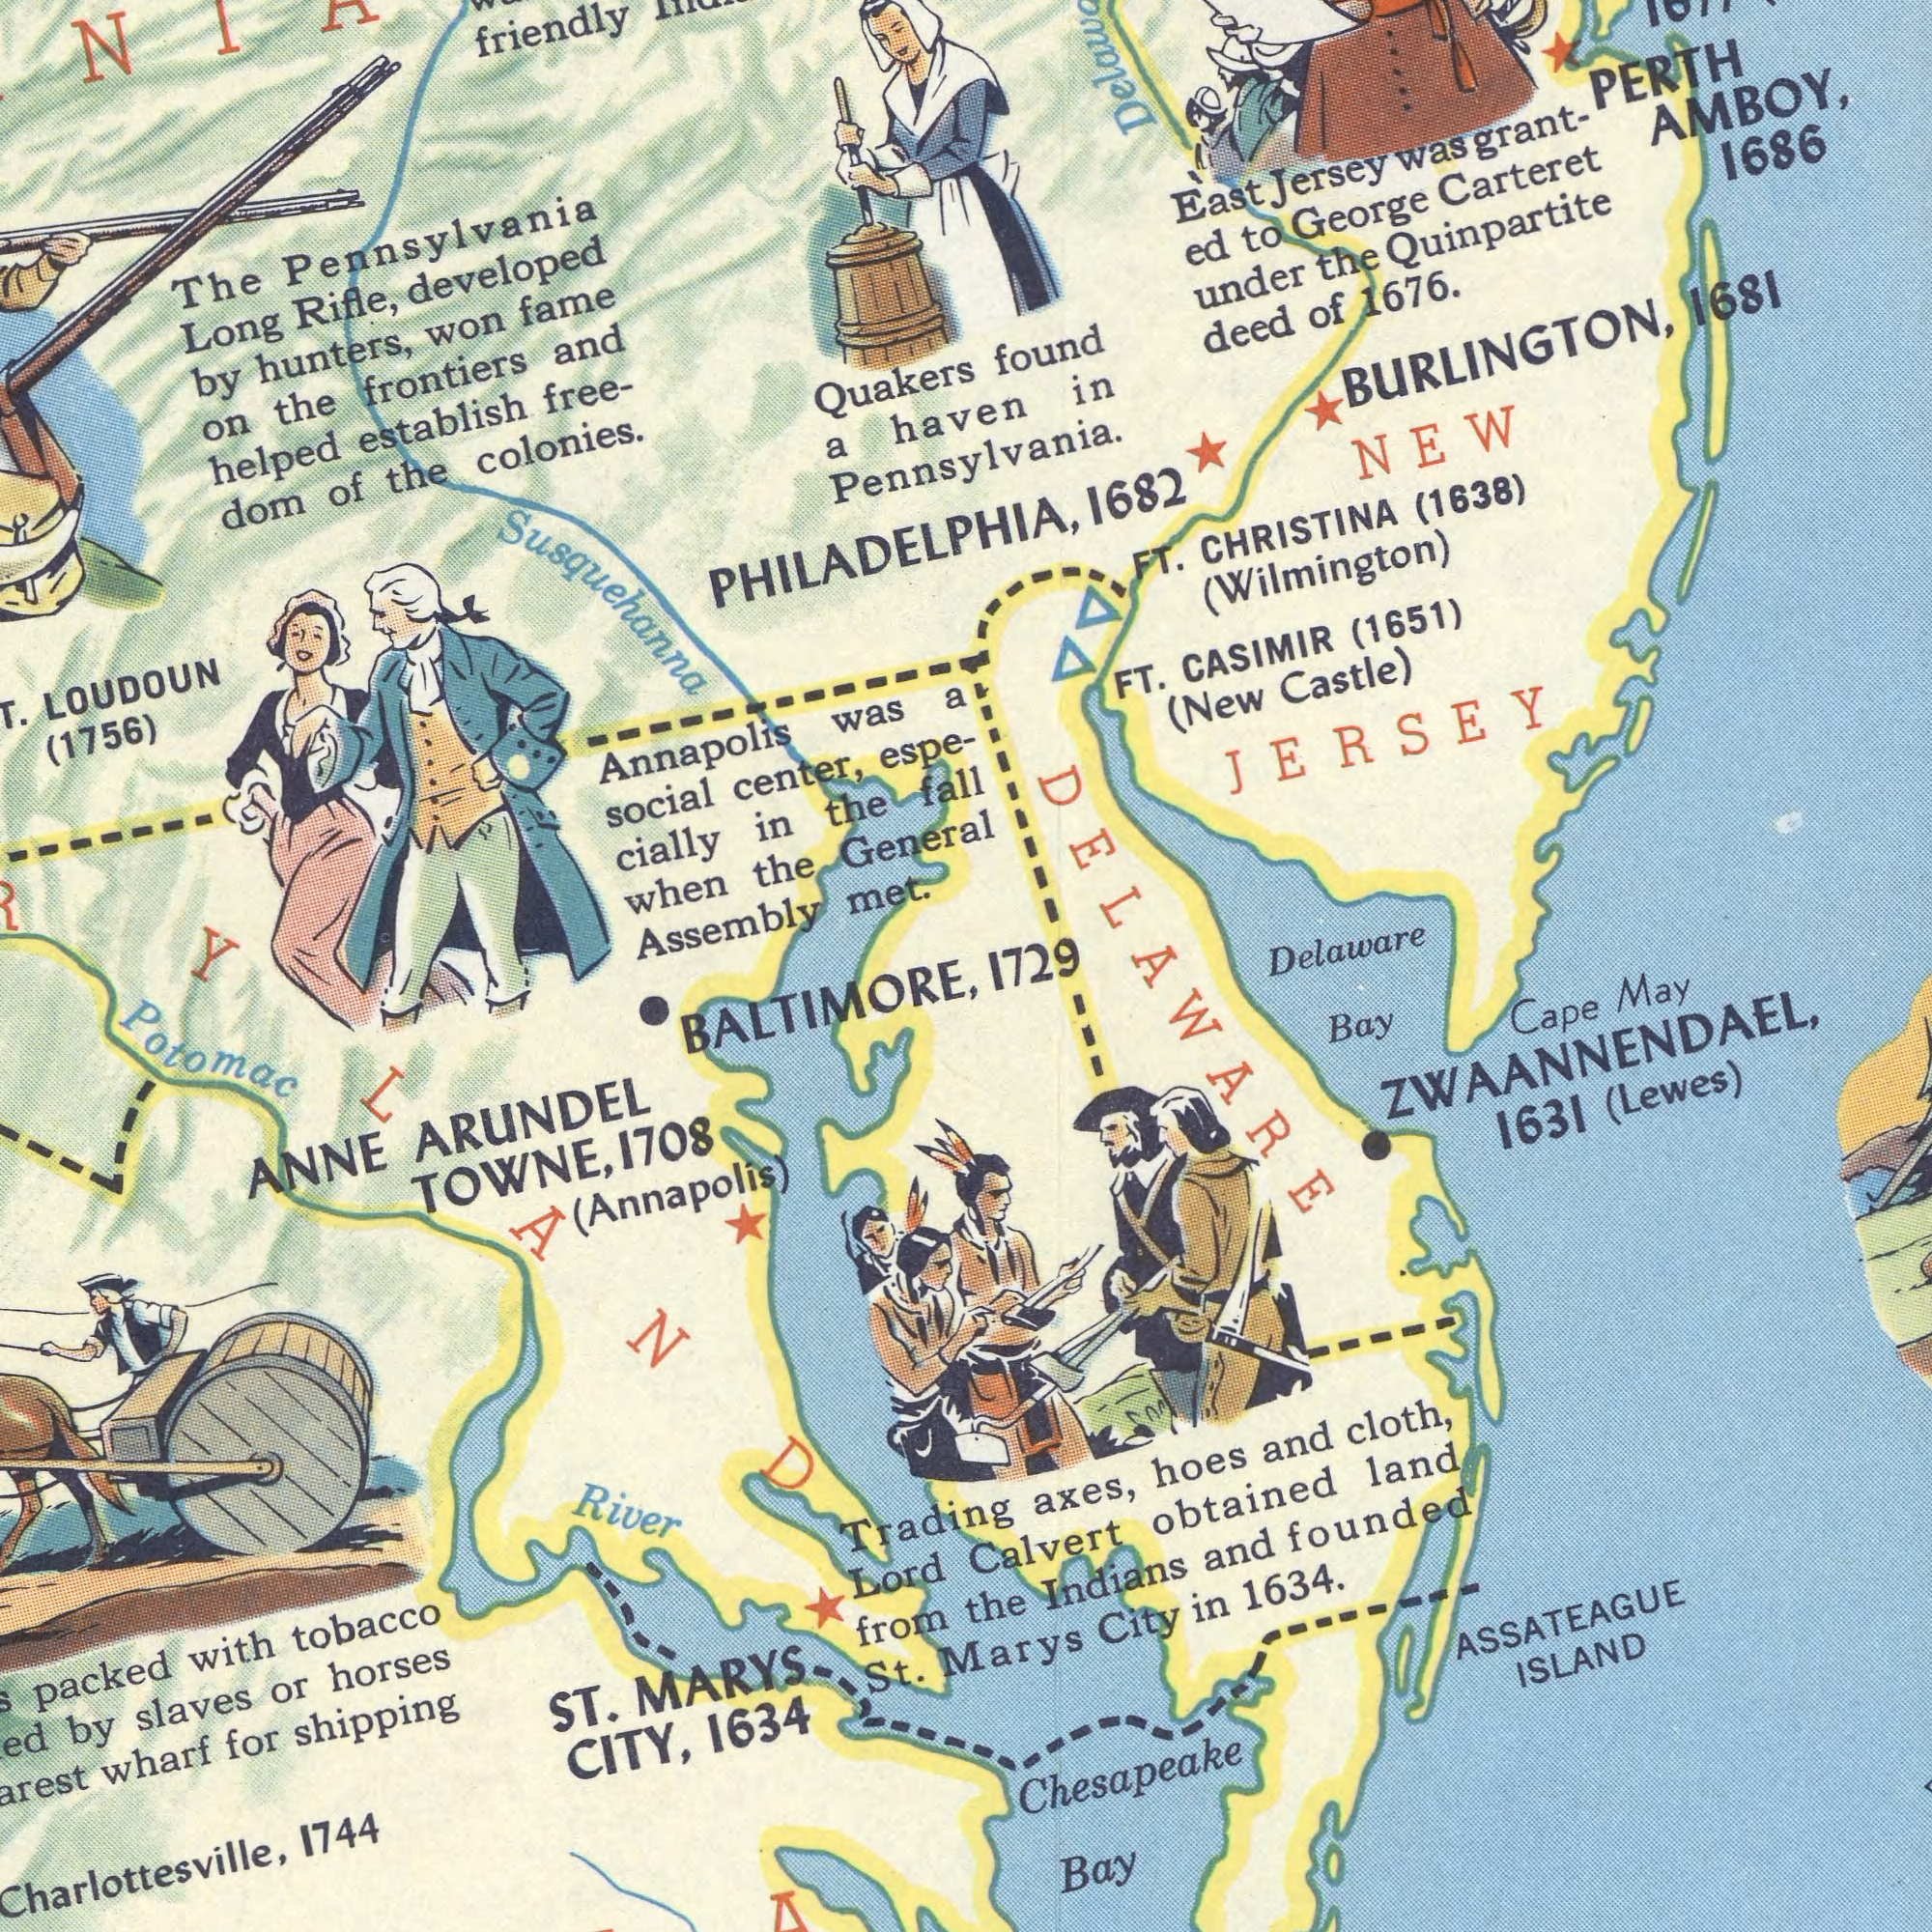What text is shown in the top-left quadrant? center, LOUDOUN hunters, Annapolis (1756) Rifle, met. establish frontiers helped social and dom colonies. Long won cially fame the espe- of was General the in The when free- by a the the on Quakers Assembly developed Pennsylvania Susquehanna friendly PHILADELPHIA, What text can you see in the top-right section? a fall 1686 PERTH Delaware found Carteret AMBOY, (New 1676. Quinpartite FT. (1651) (1638) under 1681 George 1682 of Jersey CHRISTINA (Wilmington) in deed Castle) to BURLINGTON, NEW East CASIMIR FT. ed the JERSEY haven Pennsylvania. Was grant- What text is shown in the bottom-left quadrant? CITY, wharf horses tobacco slaves 1634 packed ANNE TOWNE, Lord MARYS with (Annapolis) River 1744 1708 shipping St. from for or ST. ARUNDEL Trading by Potomac BALTIMORE, What text can you see in the bottom-right section? founded obtained 1634. ASSATEAGUE 1631 Cape Marys May cloth, Calvert Indians land Bay Bay Chesapeake and axes, and the (Lewes) ISLAND City in ZWAANNENDAEL, hoes DELAWARE 1729 